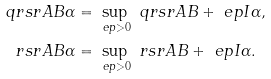<formula> <loc_0><loc_0><loc_500><loc_500>\ q r s r { A } { B } { \alpha } & = \sup _ { \ e p > 0 } \ q r s r { A } { B + \ e p I } { \alpha } , \\ \ r s r { A } { B } { \alpha } & = \sup _ { \ e p > 0 } \ r s r { A } { B + \ e p I } { \alpha } .</formula> 